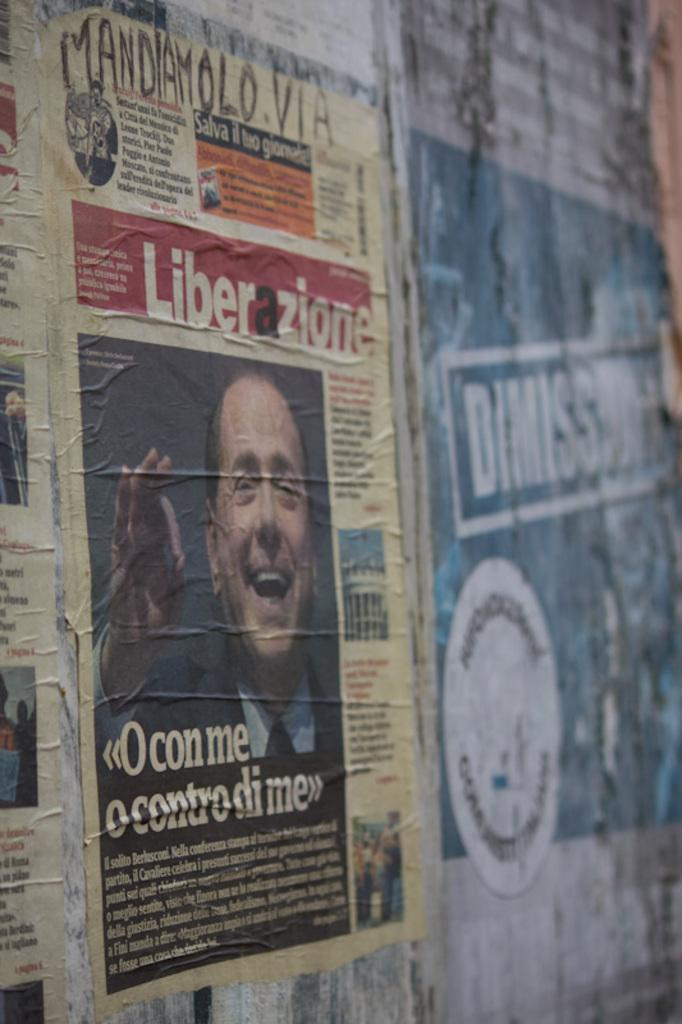What can be seen on the wall in the image? There are posts and posters on the wall in the image. What do the posters contain? The posters contain pictures and text written on them. How much tax is being paid for the cup in the image? There is no cup present in the image, and therefore no tax can be associated with it. 